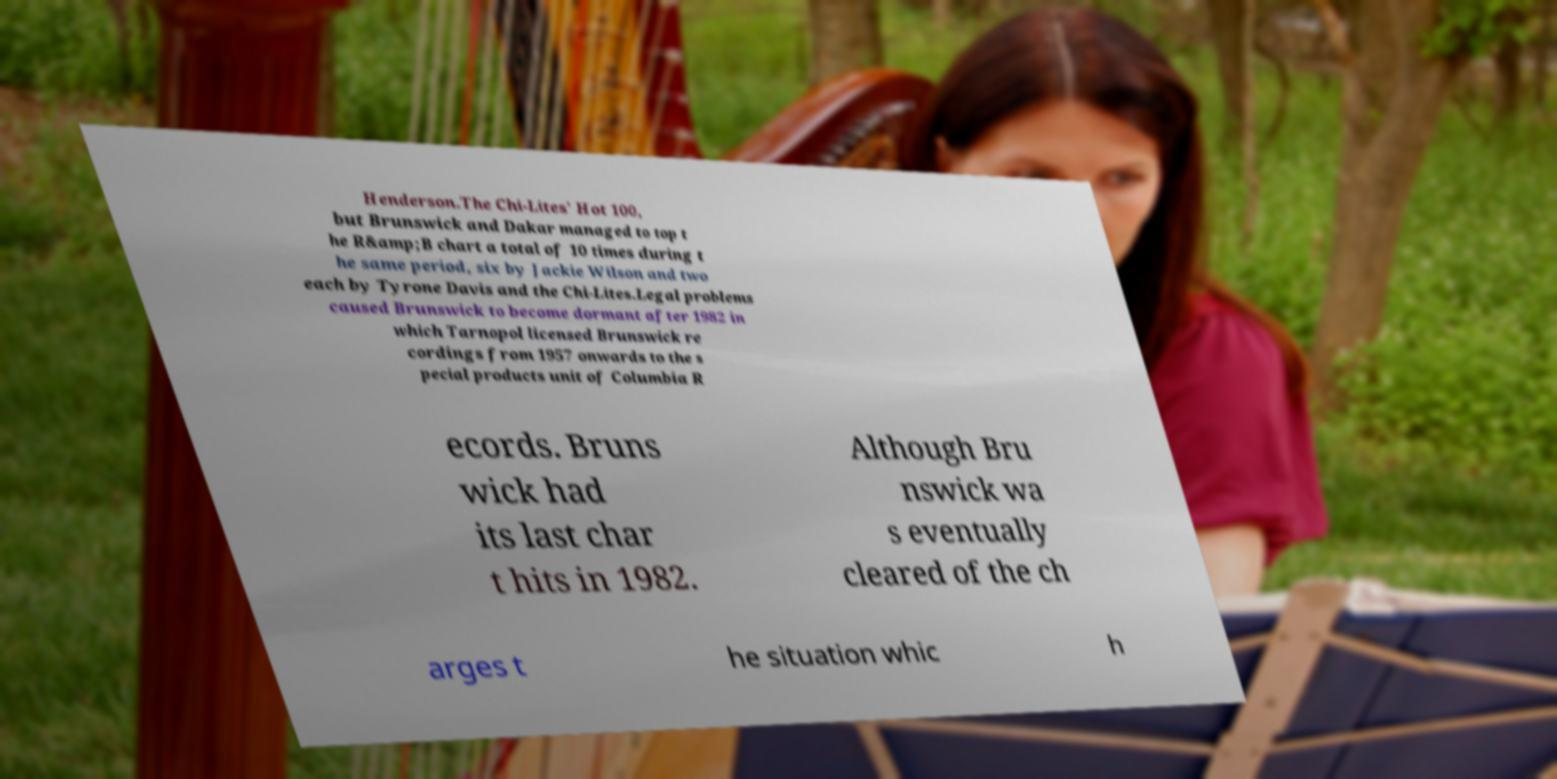Please identify and transcribe the text found in this image. Henderson.The Chi-Lites' Hot 100, but Brunswick and Dakar managed to top t he R&amp;B chart a total of 10 times during t he same period, six by Jackie Wilson and two each by Tyrone Davis and the Chi-Lites.Legal problems caused Brunswick to become dormant after 1982 in which Tarnopol licensed Brunswick re cordings from 1957 onwards to the s pecial products unit of Columbia R ecords. Bruns wick had its last char t hits in 1982. Although Bru nswick wa s eventually cleared of the ch arges t he situation whic h 